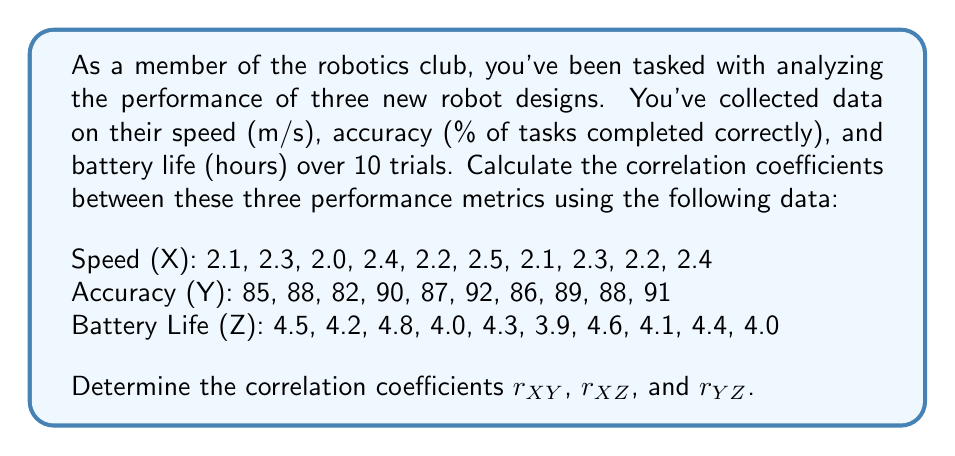Can you solve this math problem? To calculate the correlation coefficients, we'll use the formula:

$$r_{AB} = \frac{\sum_{i=1}^n (A_i - \bar{A})(B_i - \bar{B})}{\sqrt{\sum_{i=1}^n (A_i - \bar{A})^2 \sum_{i=1}^n (B_i - \bar{B})^2}}$$

Where $A$ and $B$ represent the variables we're correlating, and $\bar{A}$ and $\bar{B}$ are their respective means.

Step 1: Calculate the means
$\bar{X} = 2.25$, $\bar{Y} = 87.8$, $\bar{Z} = 4.28$

Step 2: Calculate the deviations from the mean for each variable
$(X_i - \bar{X})$, $(Y_i - \bar{Y})$, and $(Z_i - \bar{Z})$

Step 3: Calculate the products of deviations and their sums
$\sum (X_i - \bar{X})(Y_i - \bar{Y}) = 2.74$
$\sum (X_i - \bar{X})(Z_i - \bar{Z}) = -0.2025$
$\sum (Y_i - \bar{Y})(Z_i - \bar{Z}) = -7.26$

Step 4: Calculate the squared deviations and their sums
$\sum (X_i - \bar{X})^2 = 0.205$
$\sum (Y_i - \bar{Y})^2 = 98.6$
$\sum (Z_i - \bar{Z})^2 = 0.8116$

Step 5: Apply the correlation coefficient formula

For $r_{XY}$:
$$r_{XY} = \frac{2.74}{\sqrt{0.205 \times 98.6}} \approx 0.9565$$

For $r_{XZ}$:
$$r_{XZ} = \frac{-0.2025}{\sqrt{0.205 \times 0.8116}} \approx -0.4962$$

For $r_{YZ}$:
$$r_{YZ} = \frac{-7.26}{\sqrt{98.6 \times 0.8116}} \approx -0.8112$$
Answer: $r_{XY} \approx 0.9565$
$r_{XZ} \approx -0.4962$
$r_{YZ} \approx -0.8112$ 